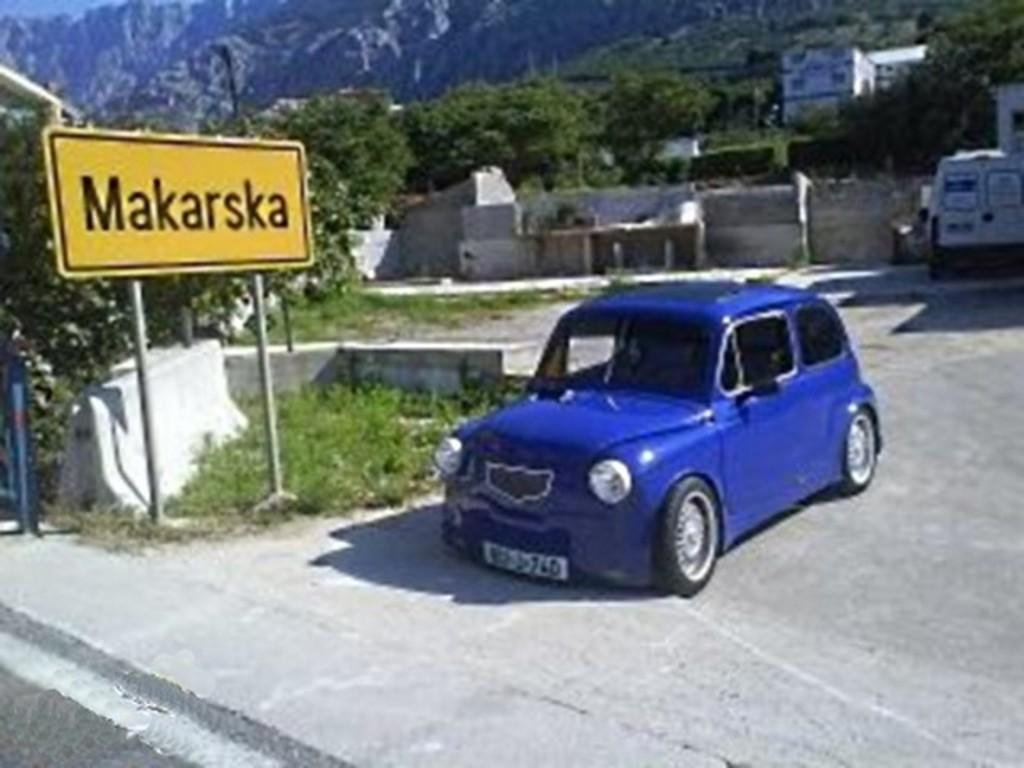What is the main feature of the image? There is a road in the image. What is on the road? There is a car on the road. What can be seen in the distance in the image? There are mountains visible in the background of the image. What type of coach can be seen driving on the road in the image? There is no coach present in the image; it features a car on the road. What type of pot is visible on the mountains in the image? There is no pot visible on the mountains in the image; only the mountains can be seen in the background. 